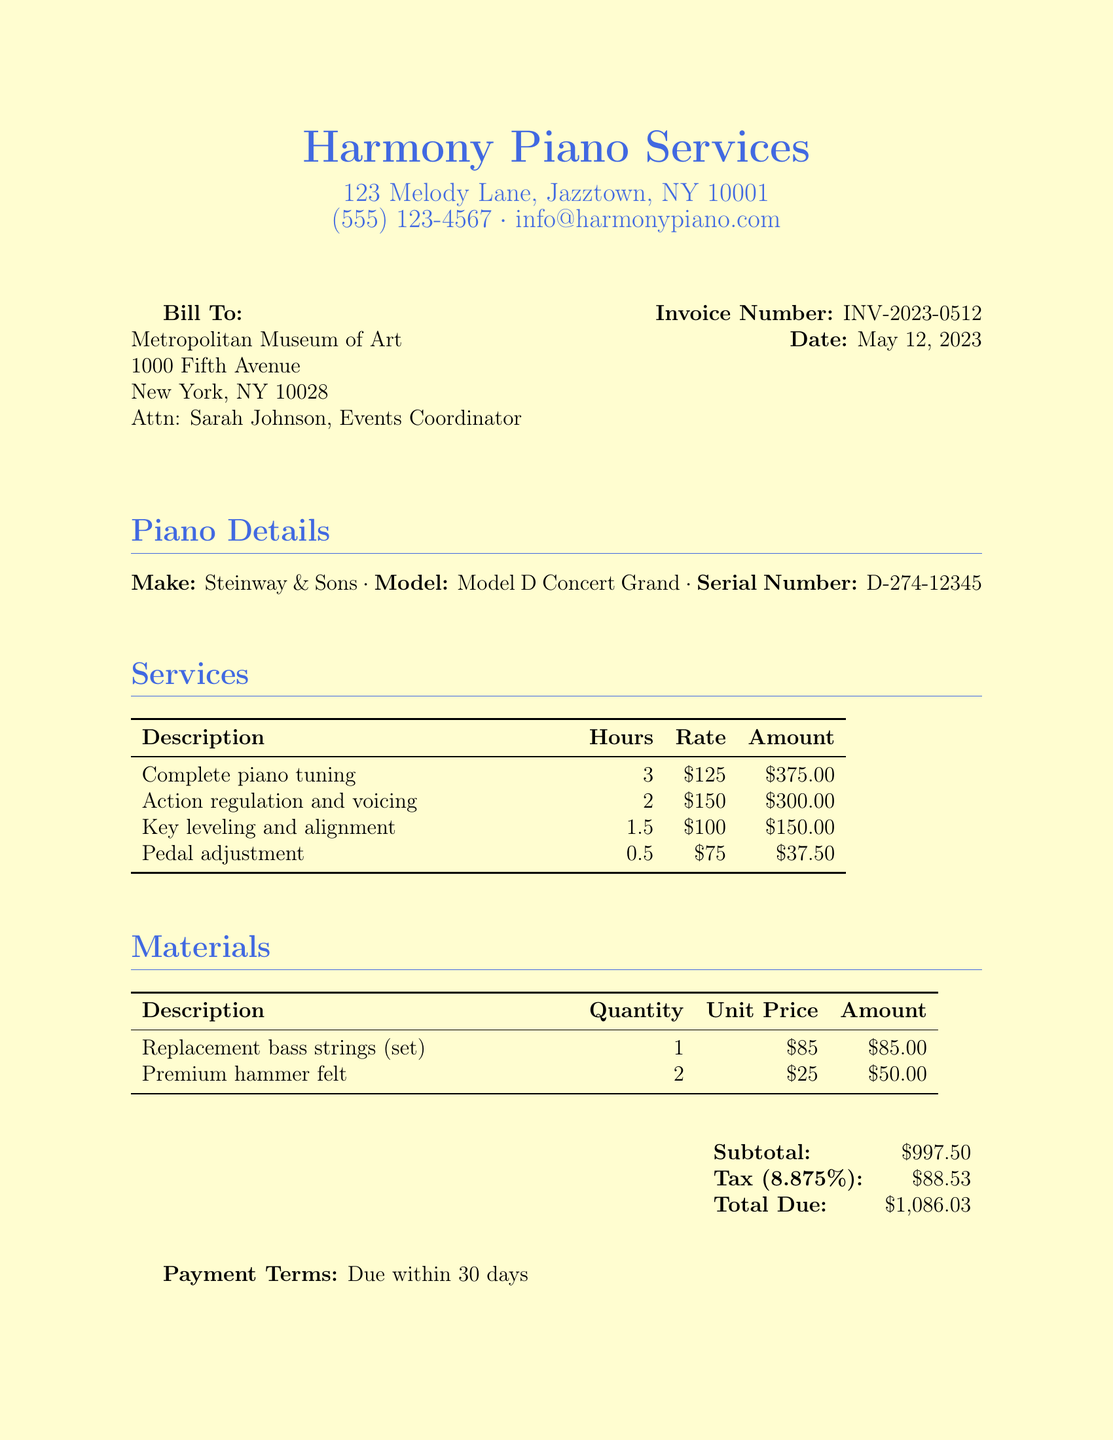What is the invoice number? The invoice number is found in the top right corner of the document.
Answer: INV-2023-0512 Who is the bill addressed to? The "Bill To" section specifies the recipient of the invoice.
Answer: Metropolitan Museum of Art What is the date of the invoice? The date is listed next to the invoice number.
Answer: May 12, 2023 How many hours were spent on complete piano tuning? The hours for the complete piano tuning service are provided in the services table.
Answer: 3 What is the total amount due? The total amount is designated in the payment summary section.
Answer: $1,086.03 What material was replaced? The materials section lists specific items that were used or replaced.
Answer: Replacement bass strings How much was charged for action regulation and voicing? The service fee is indicated in the services table next to the corresponding description.
Answer: $300.00 What percentage is the tax applied? The tax rate is stated in the payment summary section.
Answer: 8.875% How many sets of premium hammer felt were purchased? The quantity of premium hammer felt is specified in the materials table.
Answer: 2 